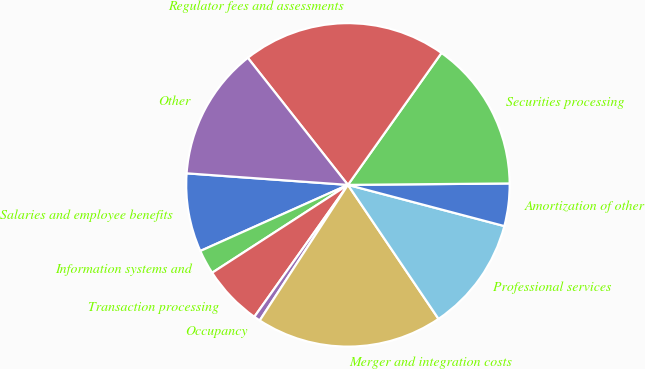Convert chart. <chart><loc_0><loc_0><loc_500><loc_500><pie_chart><fcel>Salaries and employee benefits<fcel>Information systems and<fcel>Transaction processing<fcel>Occupancy<fcel>Merger and integration costs<fcel>Professional services<fcel>Amortization of other<fcel>Securities processing<fcel>Regulator fees and assessments<fcel>Other<nl><fcel>7.84%<fcel>2.44%<fcel>6.04%<fcel>0.64%<fcel>18.64%<fcel>11.44%<fcel>4.24%<fcel>15.04%<fcel>20.44%<fcel>13.24%<nl></chart> 